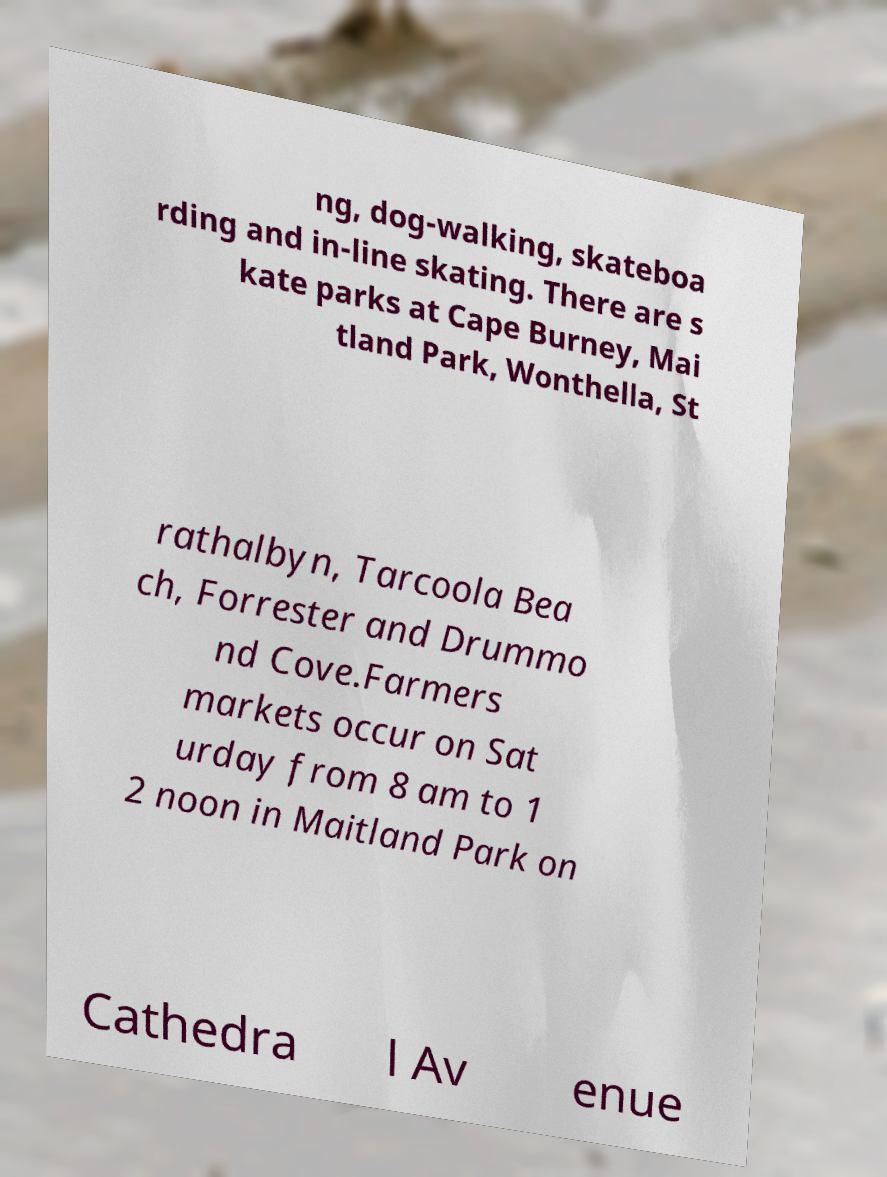Could you extract and type out the text from this image? ng, dog-walking, skateboa rding and in-line skating. There are s kate parks at Cape Burney, Mai tland Park, Wonthella, St rathalbyn, Tarcoola Bea ch, Forrester and Drummo nd Cove.Farmers markets occur on Sat urday from 8 am to 1 2 noon in Maitland Park on Cathedra l Av enue 